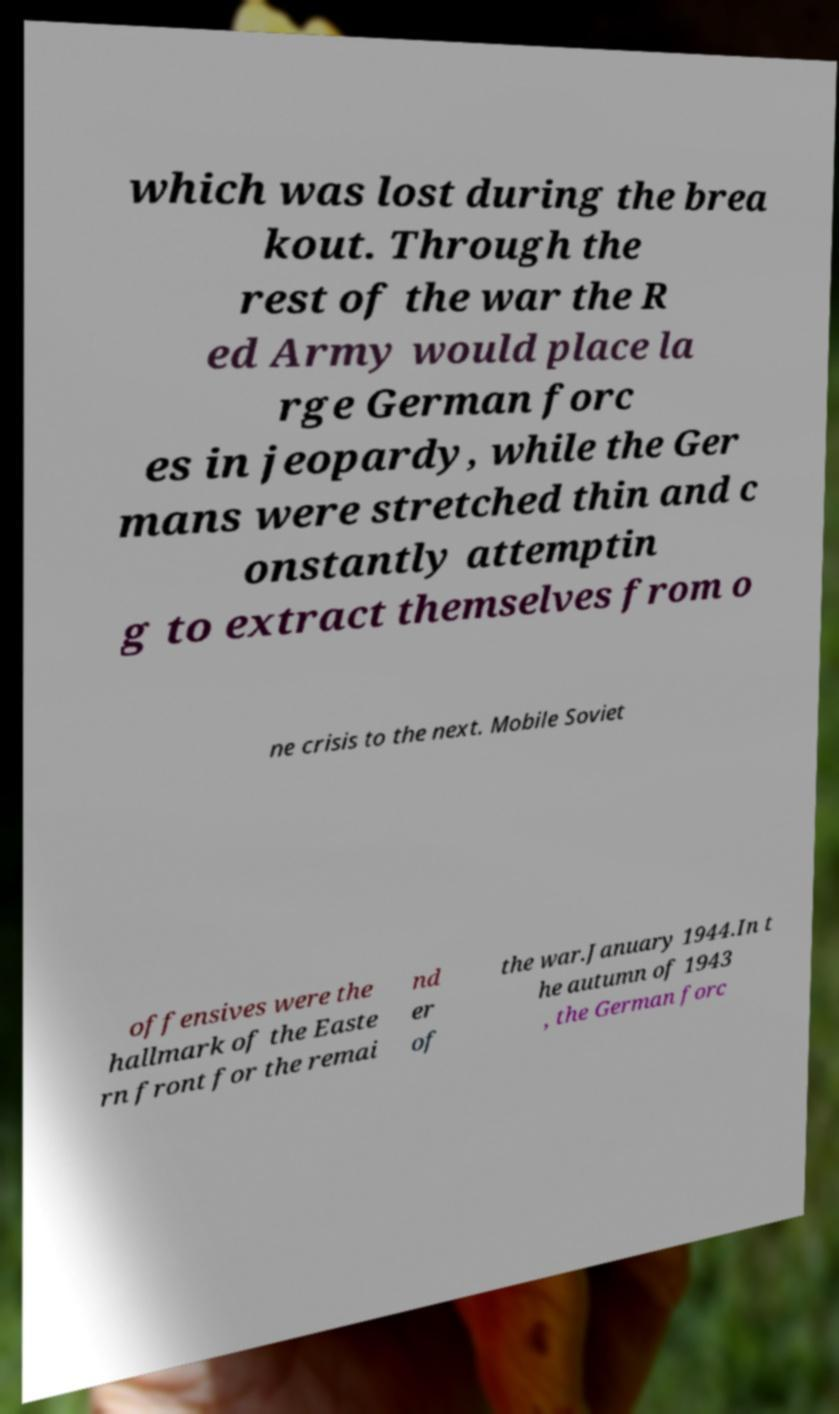There's text embedded in this image that I need extracted. Can you transcribe it verbatim? which was lost during the brea kout. Through the rest of the war the R ed Army would place la rge German forc es in jeopardy, while the Ger mans were stretched thin and c onstantly attemptin g to extract themselves from o ne crisis to the next. Mobile Soviet offensives were the hallmark of the Easte rn front for the remai nd er of the war.January 1944.In t he autumn of 1943 , the German forc 